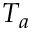<formula> <loc_0><loc_0><loc_500><loc_500>T _ { a }</formula> 